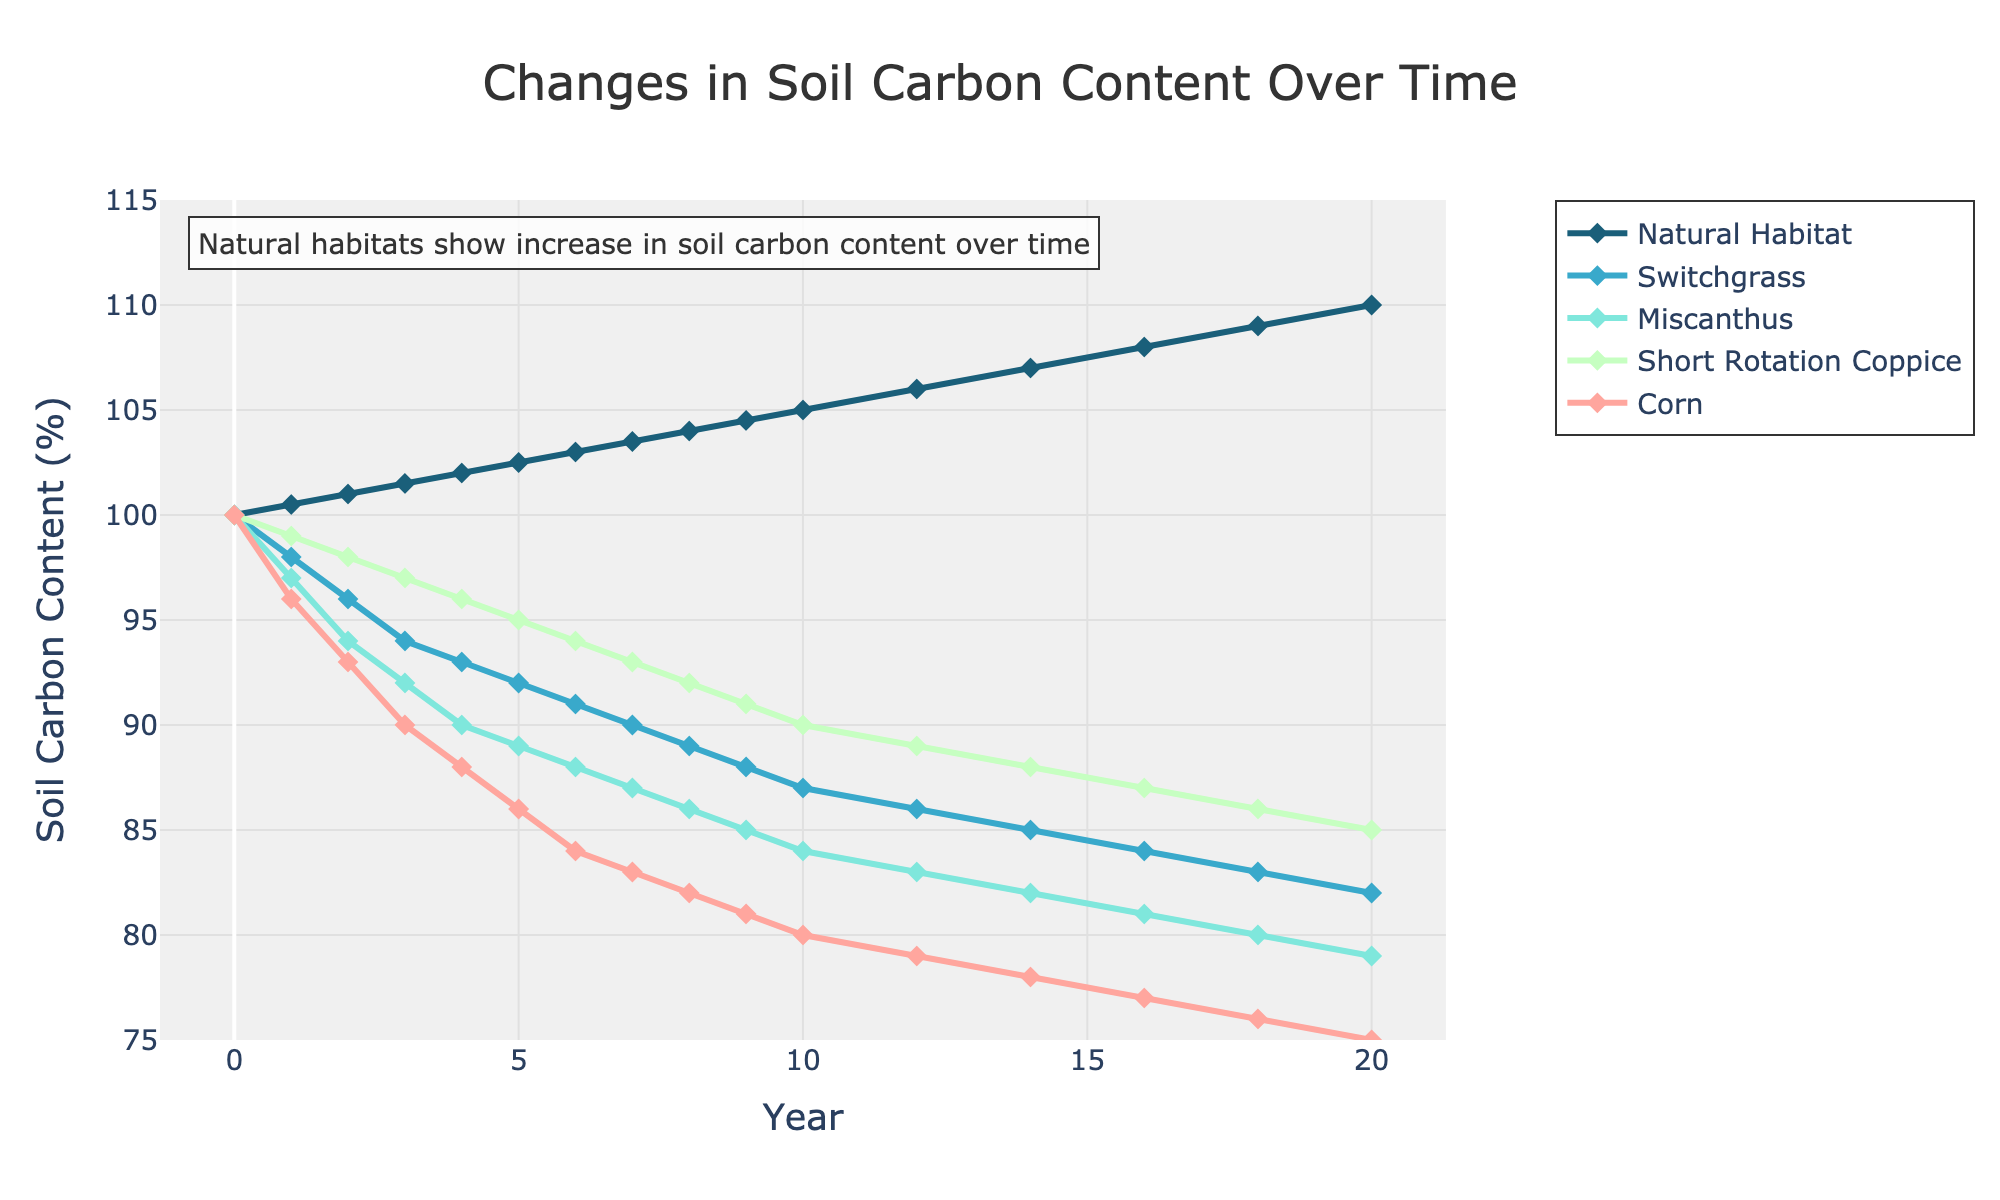How does soil carbon content in Short Rotation Coppice compare to natural habitats at Year 10? To find the comparison, look at the data points for the year 10. Short Rotation Coppice has a value of 90%, while natural habitats have 105%. We see that natural habitats have a higher soil carbon content.
Answer: Natural habitats have 15% higher soil carbon content What is the average reduction in soil carbon content for Switchgrass from Year 0 to Year 20? Switchgrass starts at 100% in Year 0 and reduces to 82% in Year 20. The reduction is 100 - 82 = 18. To find the average annual reduction, divide this by 20 years. 18 / 20 = 0.9%.
Answer: 0.9% per year Which bioenergy crop shows the smallest decrease in soil carbon content over 20 years? Examine the starting and ending soil carbon content of each bioenergy crop. Switchgrass: 100% to 82%, decrease of 18%. Miscanthus: 100% to 79%, decrease of 21%. Short Rotation Coppice: 100% to 85%, decrease of 15%. Corn: 100% to 75%, decrease of 25%. Short Rotation Coppice shows the smallest decrease.
Answer: Short Rotation Coppice By Year 5, how much has soil carbon content increased in natural habitats and decreased in Corn? Natural habitats increase from 100% to 102.5% by Year 5, which is an increase of 2.5%. Corn decreases from 100% to 86%, which is a decrease of 14%.
Answer: +2.5% for natural habitats, -14% for Corn How does the rate of soil carbon content change in Miscanthus compare to Switchgrass in the first 5 years? Miscanthus decreases from 100% to 90% in 5 years, which is a reduction of 10%. Switchgrass decreases from 100% to 92%, a reduction of 8%. Miscanthus decreases faster by 2%.
Answer: Miscanthus decreases faster by 2% Which year does Corn first fall below 80% soil carbon content? Review the data points for Corn each year. Corn falls below 80% at Year 12, where it reaches 79%.
Answer: Year 12 What visual cue indicates the trend in natural habitats' soil carbon content over time? The natural habitats' line is increasing in height from left to right, suggesting an upward trend over the years. Additionally, the annotation text highlights the increase in carbon content.
Answer: Increasing line height If one were to average the soil carbon content across all bioenergy crops at Year 10, what would be the value? At Year 10, Switchgrass: 87%, Miscanthus: 84%, Short Rotation Coppice: 90%, Corn: 80%. Summing these gives 87 + 84 + 90 + 80 = 341. Dividing by the 4 crops makes the average 341/4 = 85.25%.
Answer: 85.25% What is the general trend for soil carbon content in bioenergy crops compared to natural habitats over 20 years? Bioenergy crops show a consistent decrease in soil carbon content over time, while natural habitats show an increase. This is indicated by the declining lines for bioenergy crops and the upward line for natural habitats.
Answer: Decrease for bioenergy, increase for natural habitats 